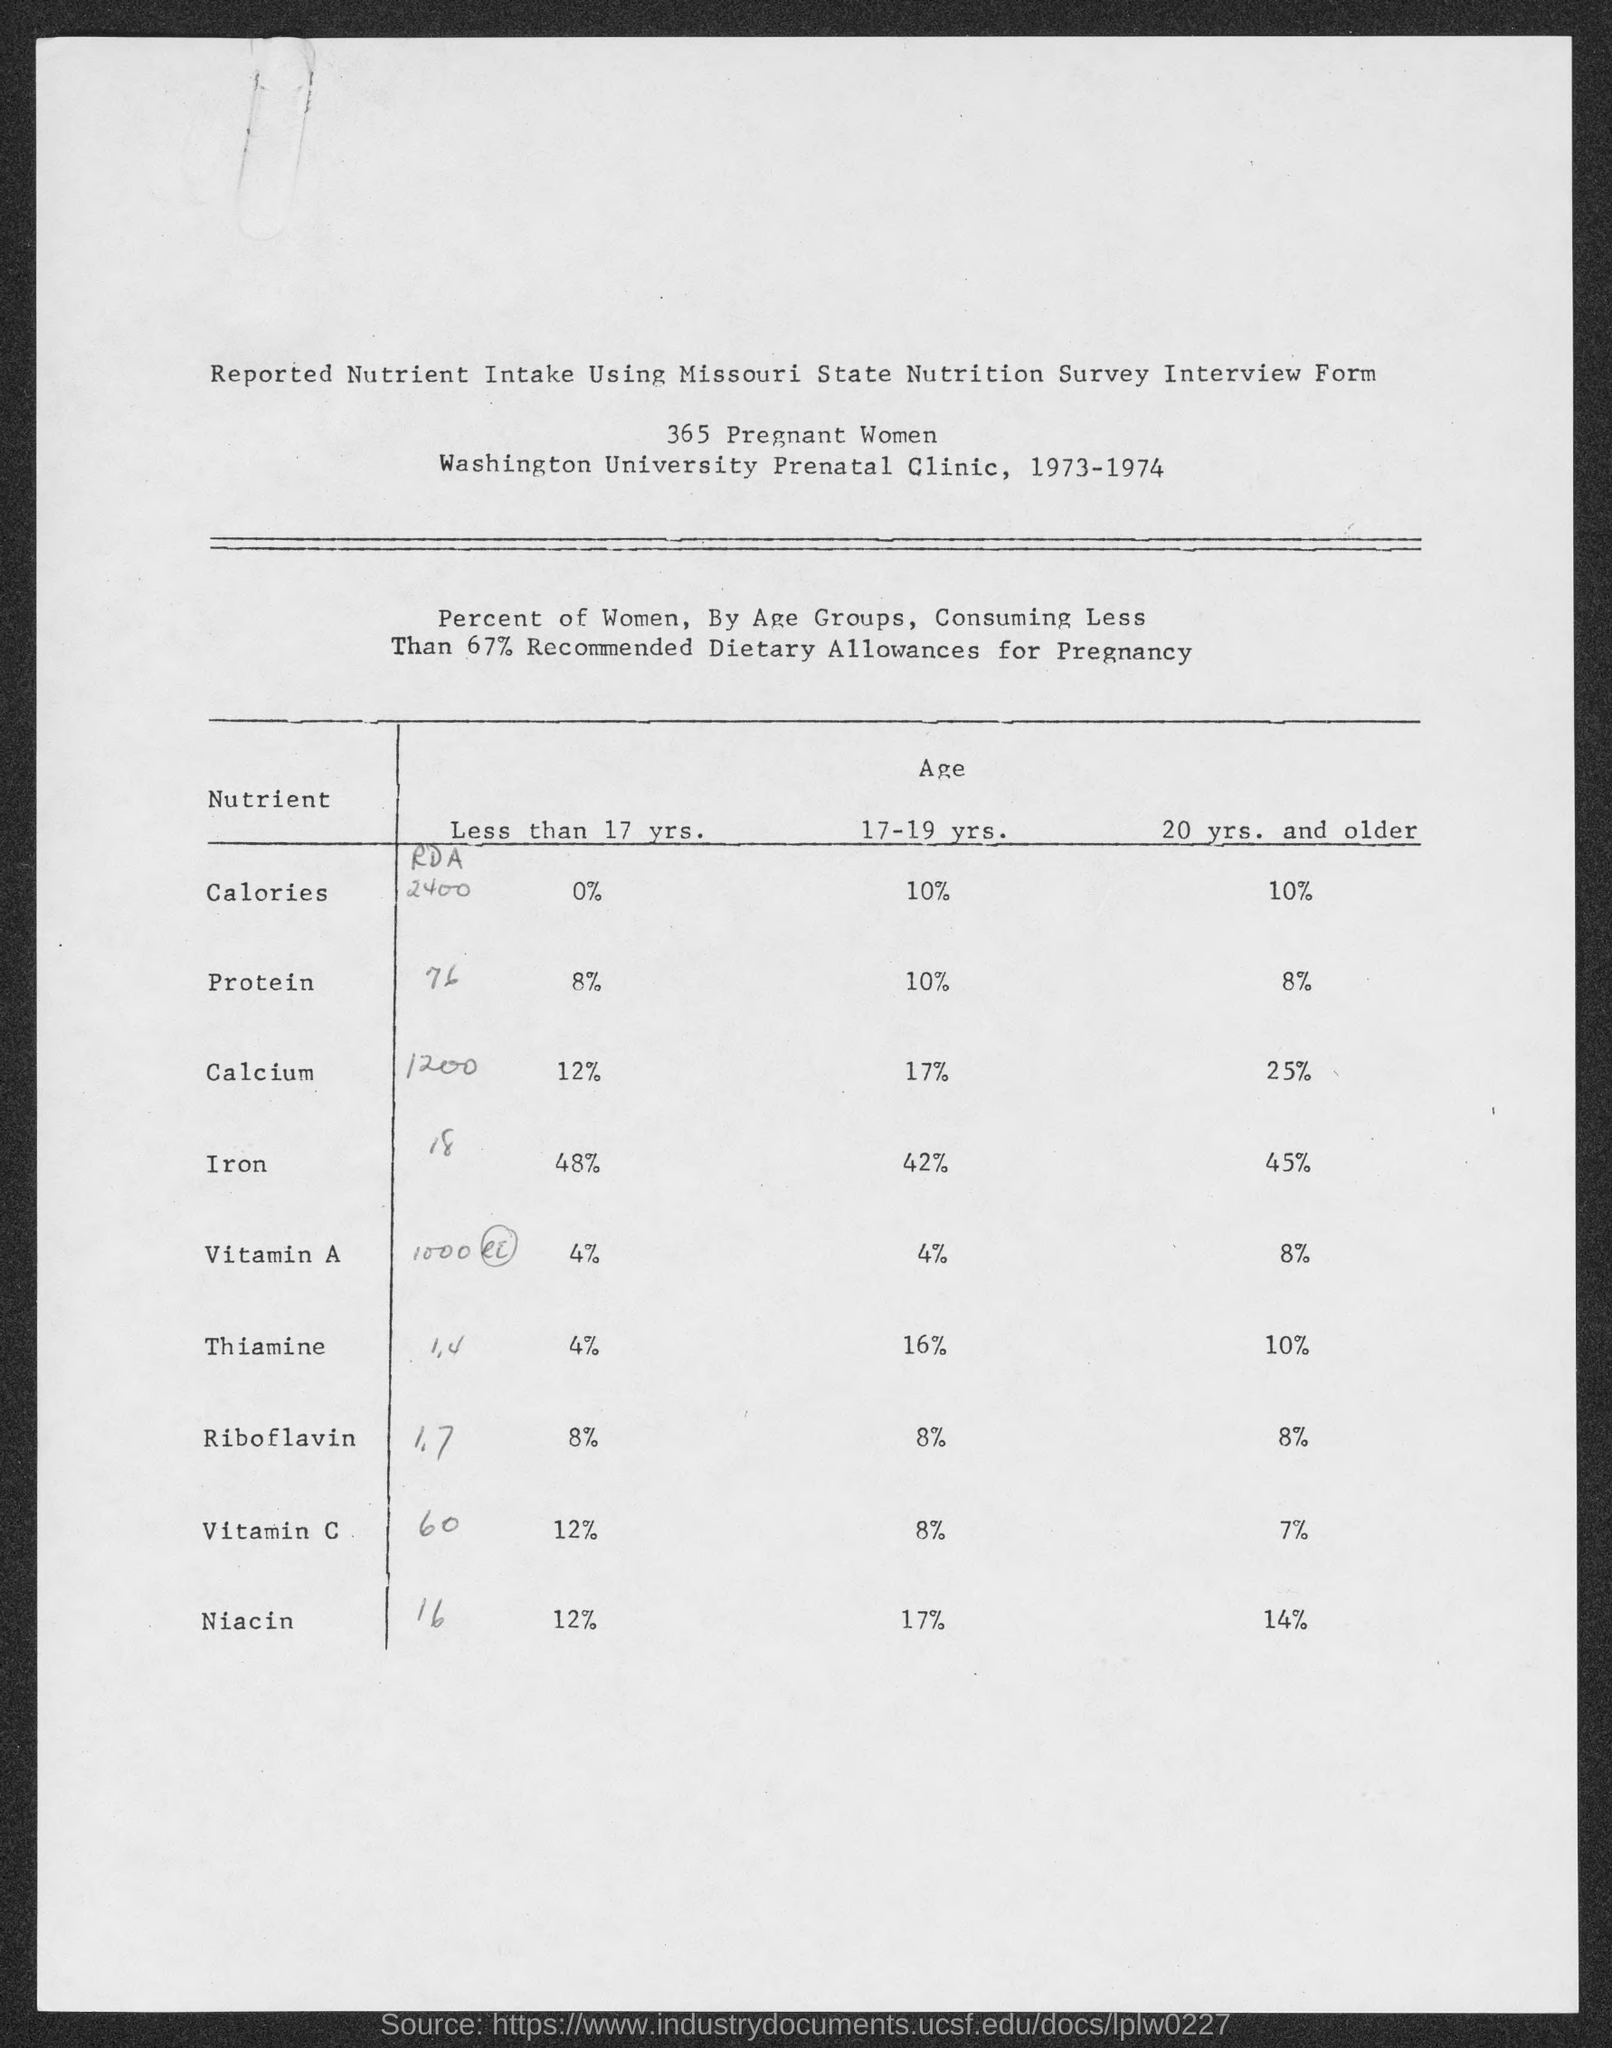Specify some key components in this picture. The recommended daily intake of thiamine for women under the age of 17 is 4%. According to the percentage of protein for women under the age of 17, it is recommended that women consume 8% of their daily calories from protein. Niacin is an essential nutrient that helps the body convert food into energy. The recommended daily intake of niacin for women under 17 years old is 12%. It is important to maintain healthy levels of niacin in the diet to support overall health and wellbeing. According to the given information, the percentage of calcium for women whose age ranges from 17 to 19 years old is 17%. Approximately 4% of the recommended daily intake of vitamin A is recommended for women under the age of 17. 